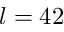<formula> <loc_0><loc_0><loc_500><loc_500>l = 4 2</formula> 